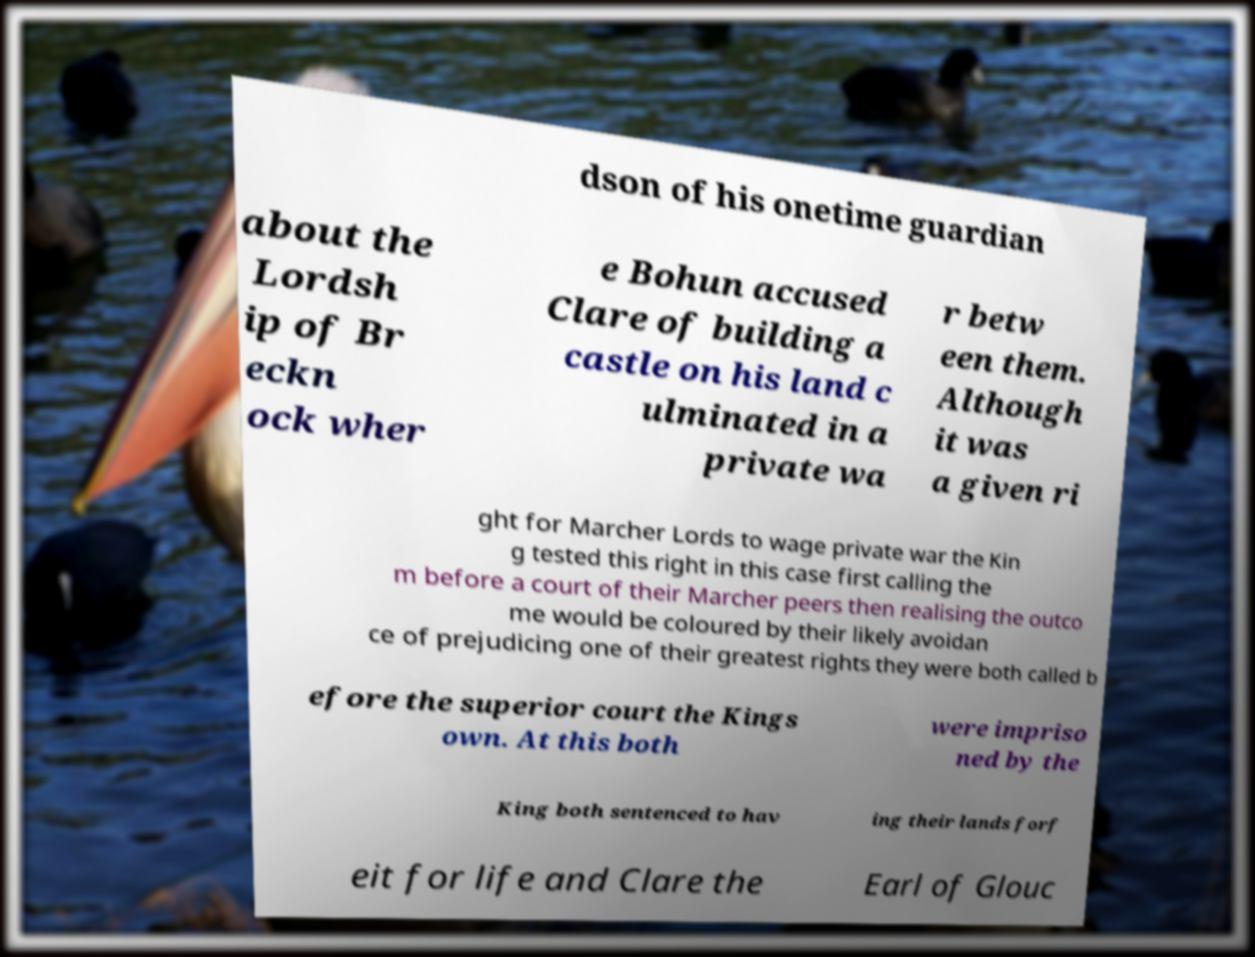Can you accurately transcribe the text from the provided image for me? dson of his onetime guardian about the Lordsh ip of Br eckn ock wher e Bohun accused Clare of building a castle on his land c ulminated in a private wa r betw een them. Although it was a given ri ght for Marcher Lords to wage private war the Kin g tested this right in this case first calling the m before a court of their Marcher peers then realising the outco me would be coloured by their likely avoidan ce of prejudicing one of their greatest rights they were both called b efore the superior court the Kings own. At this both were impriso ned by the King both sentenced to hav ing their lands forf eit for life and Clare the Earl of Glouc 